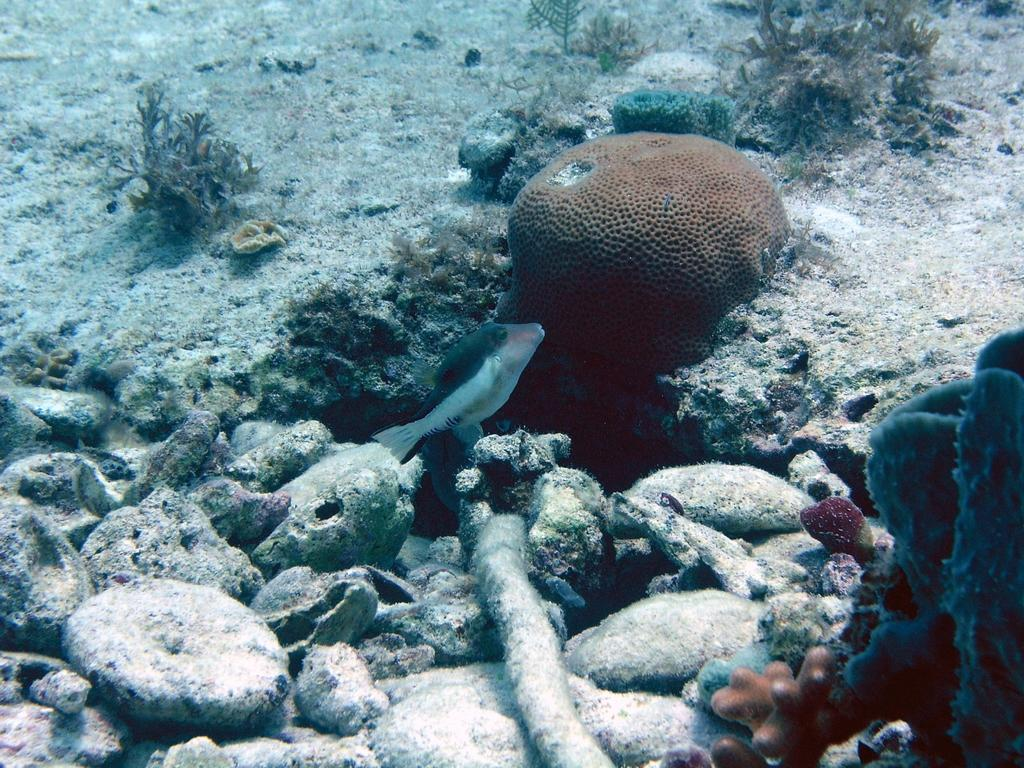What is the main subject of the image? There is a fish swimming in the water in the image. What can be seen on the land in the image? There are stones on the land in the image. What type of vegetation is visible in the background of the image? There are plants visible in the background of the image. What type of education does the fish have in the image? There is no indication of any education for the fish in the image. 